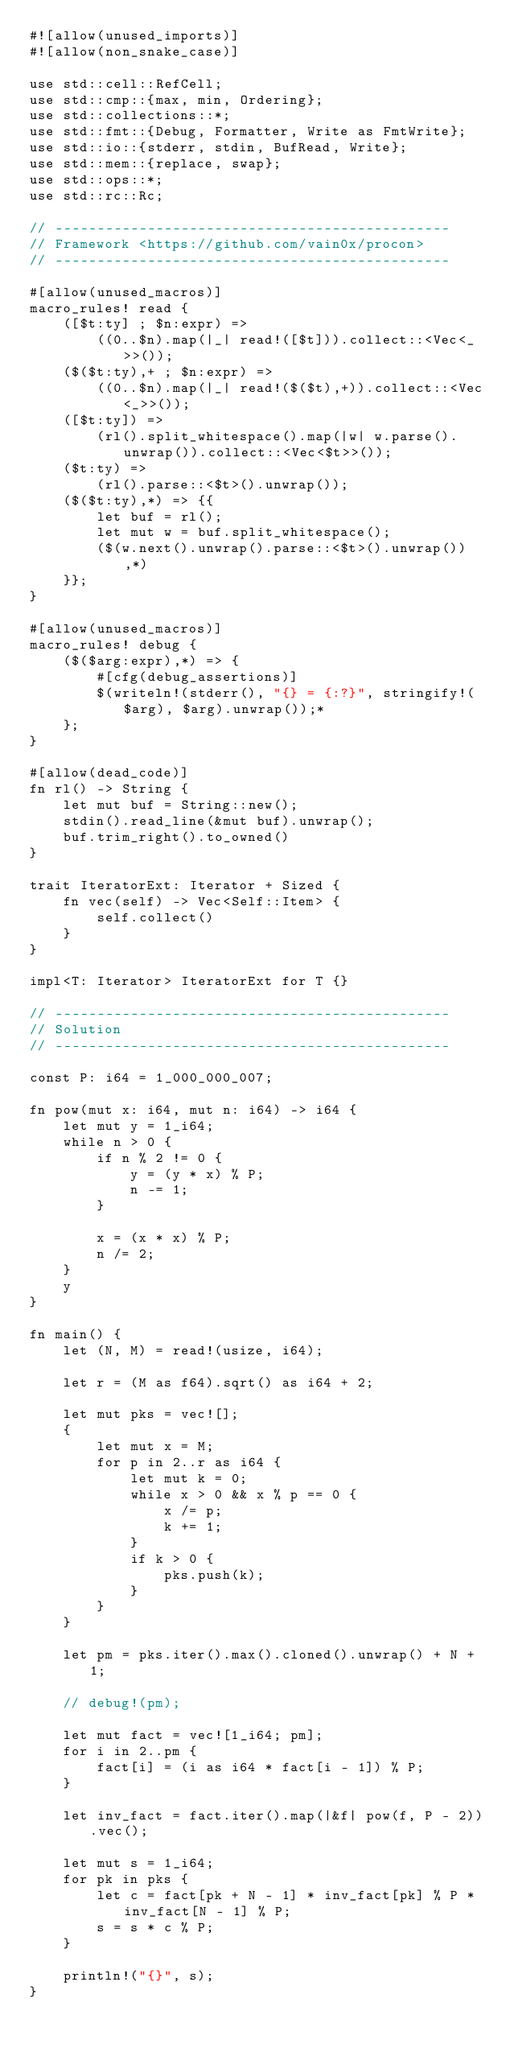Convert code to text. <code><loc_0><loc_0><loc_500><loc_500><_Rust_>#![allow(unused_imports)]
#![allow(non_snake_case)]

use std::cell::RefCell;
use std::cmp::{max, min, Ordering};
use std::collections::*;
use std::fmt::{Debug, Formatter, Write as FmtWrite};
use std::io::{stderr, stdin, BufRead, Write};
use std::mem::{replace, swap};
use std::ops::*;
use std::rc::Rc;

// -----------------------------------------------
// Framework <https://github.com/vain0x/procon>
// -----------------------------------------------

#[allow(unused_macros)]
macro_rules! read {
    ([$t:ty] ; $n:expr) =>
        ((0..$n).map(|_| read!([$t])).collect::<Vec<_>>());
    ($($t:ty),+ ; $n:expr) =>
        ((0..$n).map(|_| read!($($t),+)).collect::<Vec<_>>());
    ([$t:ty]) =>
        (rl().split_whitespace().map(|w| w.parse().unwrap()).collect::<Vec<$t>>());
    ($t:ty) =>
        (rl().parse::<$t>().unwrap());
    ($($t:ty),*) => {{
        let buf = rl();
        let mut w = buf.split_whitespace();
        ($(w.next().unwrap().parse::<$t>().unwrap()),*)
    }};
}

#[allow(unused_macros)]
macro_rules! debug {
    ($($arg:expr),*) => {
        #[cfg(debug_assertions)]
        $(writeln!(stderr(), "{} = {:?}", stringify!($arg), $arg).unwrap());*
    };
}

#[allow(dead_code)]
fn rl() -> String {
    let mut buf = String::new();
    stdin().read_line(&mut buf).unwrap();
    buf.trim_right().to_owned()
}

trait IteratorExt: Iterator + Sized {
    fn vec(self) -> Vec<Self::Item> {
        self.collect()
    }
}

impl<T: Iterator> IteratorExt for T {}

// -----------------------------------------------
// Solution
// -----------------------------------------------

const P: i64 = 1_000_000_007;

fn pow(mut x: i64, mut n: i64) -> i64 {
    let mut y = 1_i64;
    while n > 0 {
        if n % 2 != 0 {
            y = (y * x) % P;
            n -= 1;
        }

        x = (x * x) % P;
        n /= 2;
    }
    y
}

fn main() {
    let (N, M) = read!(usize, i64);

    let r = (M as f64).sqrt() as i64 + 2;

    let mut pks = vec![];
    {
        let mut x = M;
        for p in 2..r as i64 {
            let mut k = 0;
            while x > 0 && x % p == 0 {
                x /= p;
                k += 1;
            }
            if k > 0 {
                pks.push(k);
            }
        }
    }

    let pm = pks.iter().max().cloned().unwrap() + N + 1;

    // debug!(pm);

    let mut fact = vec![1_i64; pm];
    for i in 2..pm {
        fact[i] = (i as i64 * fact[i - 1]) % P;
    }

    let inv_fact = fact.iter().map(|&f| pow(f, P - 2)).vec();

    let mut s = 1_i64;
    for pk in pks {
        let c = fact[pk + N - 1] * inv_fact[pk] % P * inv_fact[N - 1] % P;
        s = s * c % P;
    }

    println!("{}", s);
}
</code> 